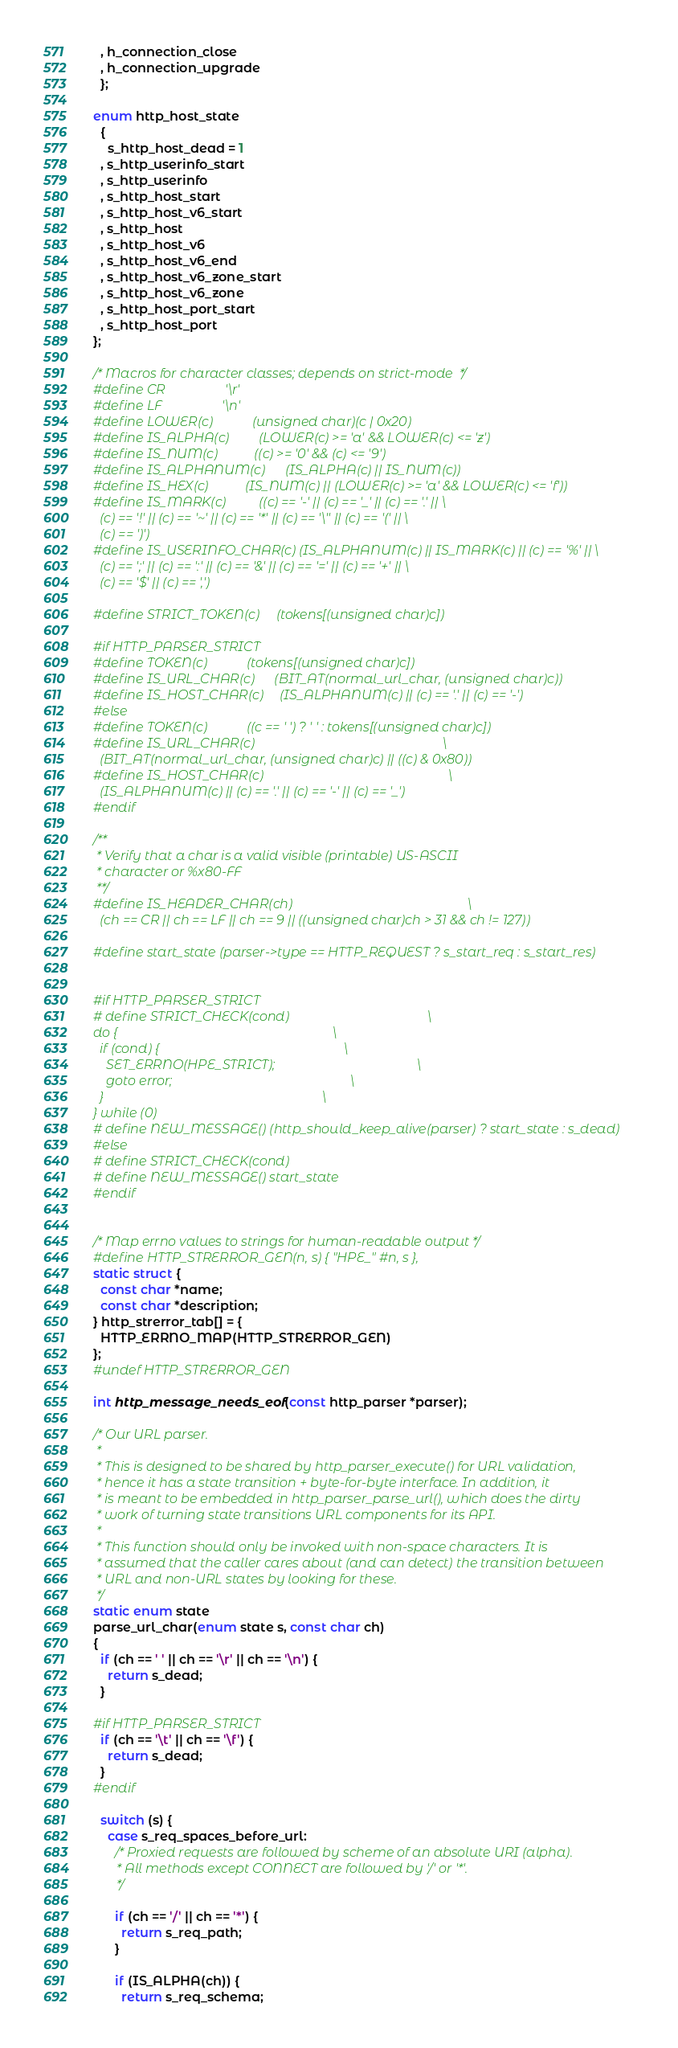Convert code to text. <code><loc_0><loc_0><loc_500><loc_500><_C++_>  , h_connection_close
  , h_connection_upgrade
  };

enum http_host_state
  {
    s_http_host_dead = 1
  , s_http_userinfo_start
  , s_http_userinfo
  , s_http_host_start
  , s_http_host_v6_start
  , s_http_host
  , s_http_host_v6
  , s_http_host_v6_end
  , s_http_host_v6_zone_start
  , s_http_host_v6_zone
  , s_http_host_port_start
  , s_http_host_port
};

/* Macros for character classes; depends on strict-mode  */
#define CR                  '\r'
#define LF                  '\n'
#define LOWER(c)            (unsigned char)(c | 0x20)
#define IS_ALPHA(c)         (LOWER(c) >= 'a' && LOWER(c) <= 'z')
#define IS_NUM(c)           ((c) >= '0' && (c) <= '9')
#define IS_ALPHANUM(c)      (IS_ALPHA(c) || IS_NUM(c))
#define IS_HEX(c)           (IS_NUM(c) || (LOWER(c) >= 'a' && LOWER(c) <= 'f'))
#define IS_MARK(c)          ((c) == '-' || (c) == '_' || (c) == '.' || \
  (c) == '!' || (c) == '~' || (c) == '*' || (c) == '\'' || (c) == '(' || \
  (c) == ')')
#define IS_USERINFO_CHAR(c) (IS_ALPHANUM(c) || IS_MARK(c) || (c) == '%' || \
  (c) == ';' || (c) == ':' || (c) == '&' || (c) == '=' || (c) == '+' || \
  (c) == '$' || (c) == ',')

#define STRICT_TOKEN(c)     (tokens[(unsigned char)c])

#if HTTP_PARSER_STRICT
#define TOKEN(c)            (tokens[(unsigned char)c])
#define IS_URL_CHAR(c)      (BIT_AT(normal_url_char, (unsigned char)c))
#define IS_HOST_CHAR(c)     (IS_ALPHANUM(c) || (c) == '.' || (c) == '-')
#else
#define TOKEN(c)            ((c == ' ') ? ' ' : tokens[(unsigned char)c])
#define IS_URL_CHAR(c)                                                         \
  (BIT_AT(normal_url_char, (unsigned char)c) || ((c) & 0x80))
#define IS_HOST_CHAR(c)                                                        \
  (IS_ALPHANUM(c) || (c) == '.' || (c) == '-' || (c) == '_')
#endif

/**
 * Verify that a char is a valid visible (printable) US-ASCII
 * character or %x80-FF
 **/
#define IS_HEADER_CHAR(ch)                                                     \
  (ch == CR || ch == LF || ch == 9 || ((unsigned char)ch > 31 && ch != 127))

#define start_state (parser->type == HTTP_REQUEST ? s_start_req : s_start_res)


#if HTTP_PARSER_STRICT
# define STRICT_CHECK(cond)                                          \
do {                                                                 \
  if (cond) {                                                        \
    SET_ERRNO(HPE_STRICT);                                           \
    goto error;                                                      \
  }                                                                  \
} while (0)
# define NEW_MESSAGE() (http_should_keep_alive(parser) ? start_state : s_dead)
#else
# define STRICT_CHECK(cond)
# define NEW_MESSAGE() start_state
#endif


/* Map errno values to strings for human-readable output */
#define HTTP_STRERROR_GEN(n, s) { "HPE_" #n, s },
static struct {
  const char *name;
  const char *description;
} http_strerror_tab[] = {
  HTTP_ERRNO_MAP(HTTP_STRERROR_GEN)
};
#undef HTTP_STRERROR_GEN

int http_message_needs_eof(const http_parser *parser);

/* Our URL parser.
 *
 * This is designed to be shared by http_parser_execute() for URL validation,
 * hence it has a state transition + byte-for-byte interface. In addition, it
 * is meant to be embedded in http_parser_parse_url(), which does the dirty
 * work of turning state transitions URL components for its API.
 *
 * This function should only be invoked with non-space characters. It is
 * assumed that the caller cares about (and can detect) the transition between
 * URL and non-URL states by looking for these.
 */
static enum state
parse_url_char(enum state s, const char ch)
{
  if (ch == ' ' || ch == '\r' || ch == '\n') {
    return s_dead;
  }

#if HTTP_PARSER_STRICT
  if (ch == '\t' || ch == '\f') {
    return s_dead;
  }
#endif

  switch (s) {
    case s_req_spaces_before_url:
      /* Proxied requests are followed by scheme of an absolute URI (alpha).
       * All methods except CONNECT are followed by '/' or '*'.
       */

      if (ch == '/' || ch == '*') {
        return s_req_path;
      }

      if (IS_ALPHA(ch)) {
        return s_req_schema;</code> 